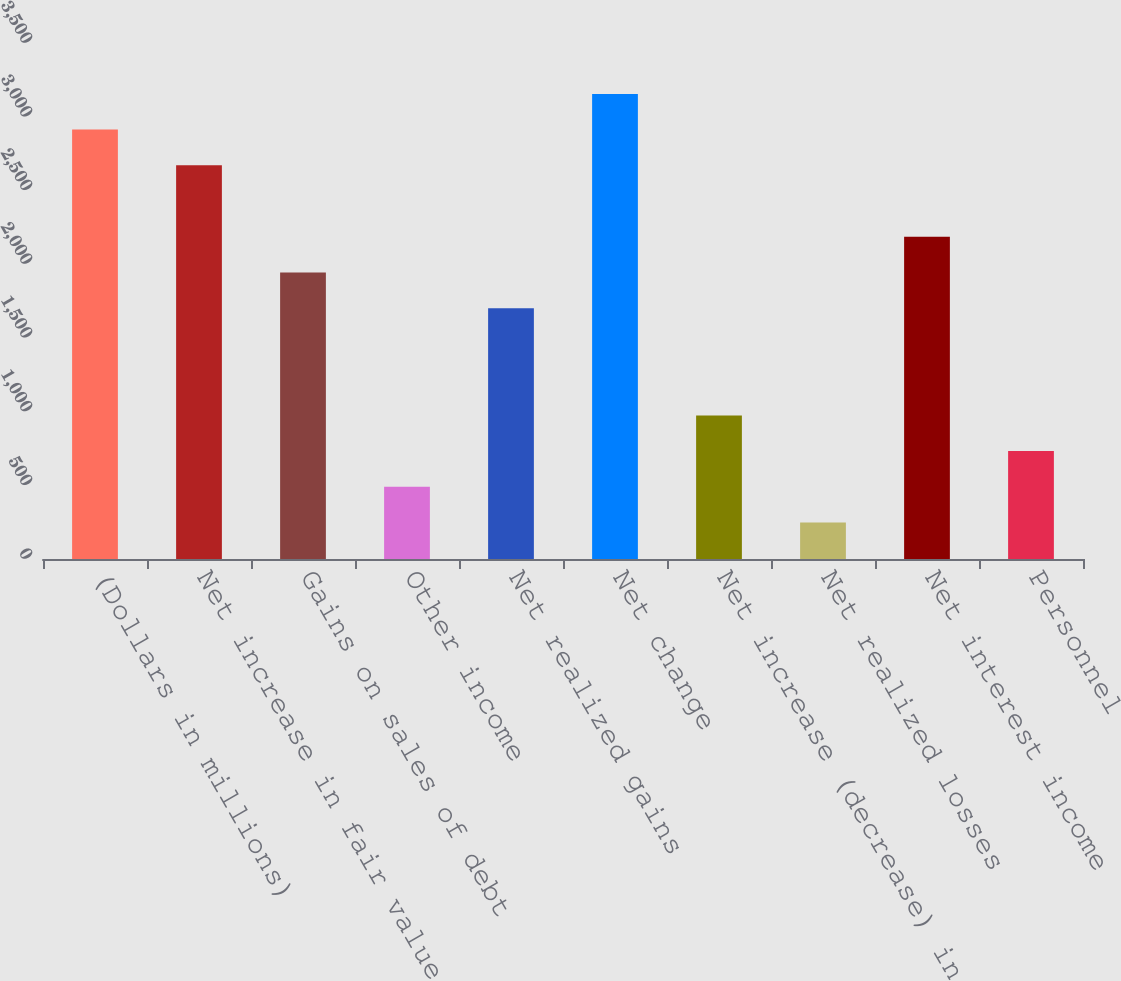Convert chart. <chart><loc_0><loc_0><loc_500><loc_500><bar_chart><fcel>(Dollars in millions)<fcel>Net increase in fair value<fcel>Gains on sales of debt<fcel>Other income<fcel>Net realized gains<fcel>Net change<fcel>Net increase (decrease) in<fcel>Net realized losses<fcel>Net interest income<fcel>Personnel<nl><fcel>2912.6<fcel>2670.3<fcel>1943.4<fcel>489.6<fcel>1701.1<fcel>3154.9<fcel>974.2<fcel>247.3<fcel>2185.7<fcel>731.9<nl></chart> 